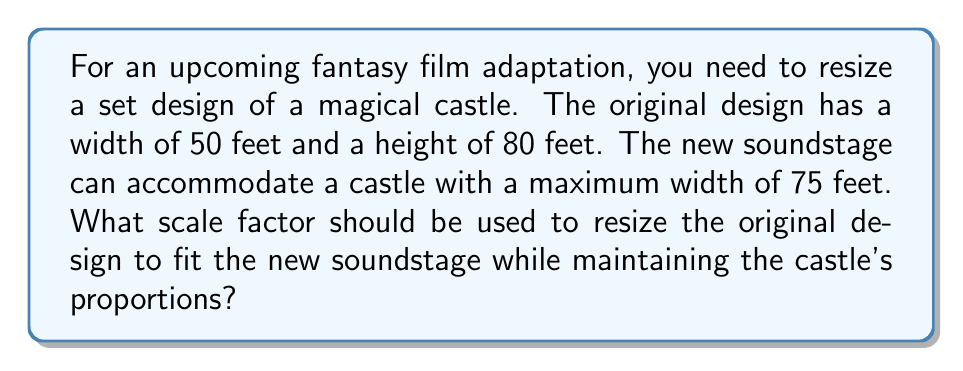What is the answer to this math problem? To solve this problem, we need to follow these steps:

1) First, we need to understand that the scale factor will be the same for both width and height to maintain proportions.

2) We can find the scale factor by dividing the new width by the original width:

   Scale factor = New width / Original width
   
   $$\text{Scale factor} = \frac{\text{New width}}{\text{Original width}} = \frac{75 \text{ feet}}{50 \text{ feet}}$$

3) Simplify the fraction:

   $$\text{Scale factor} = \frac{75}{50} = \frac{3}{2} = 1.5$$

4) To verify, let's check if this scale factor works for both dimensions:

   New width: $50 \text{ feet} \times 1.5 = 75 \text{ feet}$ (matches the given maximum)
   New height: $80 \text{ feet} \times 1.5 = 120 \text{ feet}$

5) The proportions are maintained because both dimensions are multiplied by the same factor.

Therefore, the scale factor needed to resize the set design while maintaining proportions is 1.5 or 3/2.
Answer: 1.5 